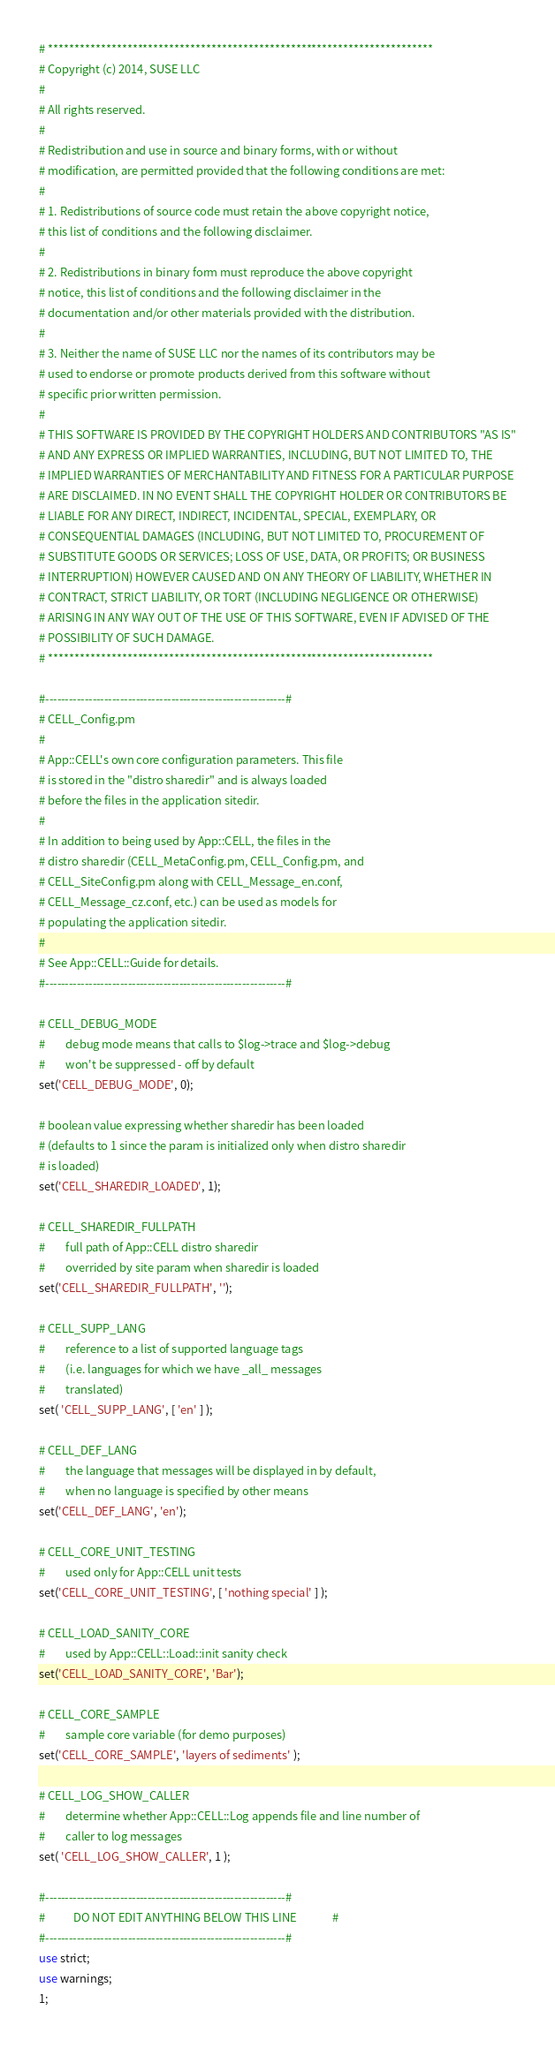Convert code to text. <code><loc_0><loc_0><loc_500><loc_500><_Perl_># ************************************************************************* 
# Copyright (c) 2014, SUSE LLC
# 
# All rights reserved.
# 
# Redistribution and use in source and binary forms, with or without
# modification, are permitted provided that the following conditions are met:
# 
# 1. Redistributions of source code must retain the above copyright notice,
# this list of conditions and the following disclaimer.
# 
# 2. Redistributions in binary form must reproduce the above copyright
# notice, this list of conditions and the following disclaimer in the
# documentation and/or other materials provided with the distribution.
# 
# 3. Neither the name of SUSE LLC nor the names of its contributors may be
# used to endorse or promote products derived from this software without
# specific prior written permission.
# 
# THIS SOFTWARE IS PROVIDED BY THE COPYRIGHT HOLDERS AND CONTRIBUTORS "AS IS"
# AND ANY EXPRESS OR IMPLIED WARRANTIES, INCLUDING, BUT NOT LIMITED TO, THE
# IMPLIED WARRANTIES OF MERCHANTABILITY AND FITNESS FOR A PARTICULAR PURPOSE
# ARE DISCLAIMED. IN NO EVENT SHALL THE COPYRIGHT HOLDER OR CONTRIBUTORS BE
# LIABLE FOR ANY DIRECT, INDIRECT, INCIDENTAL, SPECIAL, EXEMPLARY, OR
# CONSEQUENTIAL DAMAGES (INCLUDING, BUT NOT LIMITED TO, PROCUREMENT OF
# SUBSTITUTE GOODS OR SERVICES; LOSS OF USE, DATA, OR PROFITS; OR BUSINESS
# INTERRUPTION) HOWEVER CAUSED AND ON ANY THEORY OF LIABILITY, WHETHER IN
# CONTRACT, STRICT LIABILITY, OR TORT (INCLUDING NEGLIGENCE OR OTHERWISE)
# ARISING IN ANY WAY OUT OF THE USE OF THIS SOFTWARE, EVEN IF ADVISED OF THE
# POSSIBILITY OF SUCH DAMAGE.
# ************************************************************************* 

#-------------------------------------------------------------#
# CELL_Config.pm
#
# App::CELL's own core configuration parameters. This file
# is stored in the "distro sharedir" and is always loaded 
# before the files in the application sitedir.
#
# In addition to being used by App::CELL, the files in the
# distro sharedir (CELL_MetaConfig.pm, CELL_Config.pm, and
# CELL_SiteConfig.pm along with CELL_Message_en.conf,
# CELL_Message_cz.conf, etc.) can be used as models for 
# populating the application sitedir.
#
# See App::CELL::Guide for details.
#-------------------------------------------------------------#

# CELL_DEBUG_MODE
#        debug mode means that calls to $log->trace and $log->debug
#        won't be suppressed - off by default
set('CELL_DEBUG_MODE', 0);

# boolean value expressing whether sharedir has been loaded
# (defaults to 1 since the param is initialized only when distro sharedir
# is loaded)
set('CELL_SHAREDIR_LOADED', 1);

# CELL_SHAREDIR_FULLPATH
#        full path of App::CELL distro sharedir
#        overrided by site param when sharedir is loaded
set('CELL_SHAREDIR_FULLPATH', '');

# CELL_SUPP_LANG
#        reference to a list of supported language tags
#        (i.e. languages for which we have _all_ messages
#        translated)
set( 'CELL_SUPP_LANG', [ 'en' ] );

# CELL_DEF_LANG
#        the language that messages will be displayed in by default,
#        when no language is specified by other means
set('CELL_DEF_LANG', 'en');

# CELL_CORE_UNIT_TESTING
#        used only for App::CELL unit tests
set('CELL_CORE_UNIT_TESTING', [ 'nothing special' ] );

# CELL_LOAD_SANITY_CORE
#        used by App::CELL::Load::init sanity check
set('CELL_LOAD_SANITY_CORE', 'Bar');

# CELL_CORE_SAMPLE
#        sample core variable (for demo purposes)
set('CELL_CORE_SAMPLE', 'layers of sediments' );

# CELL_LOG_SHOW_CALLER
#        determine whether App::CELL::Log appends file and line number of
#        caller to log messages
set( 'CELL_LOG_SHOW_CALLER', 1 );

#-------------------------------------------------------------#
#           DO NOT EDIT ANYTHING BELOW THIS LINE              #
#-------------------------------------------------------------#
use strict;
use warnings;
1;
</code> 